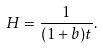<formula> <loc_0><loc_0><loc_500><loc_500>H = \frac { 1 } { ( 1 + b ) t } .</formula> 